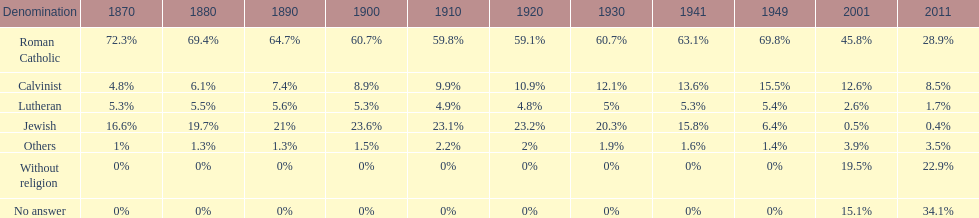Would you be able to parse every entry in this table? {'header': ['Denomination', '1870', '1880', '1890', '1900', '1910', '1920', '1930', '1941', '1949', '2001', '2011'], 'rows': [['Roman Catholic', '72.3%', '69.4%', '64.7%', '60.7%', '59.8%', '59.1%', '60.7%', '63.1%', '69.8%', '45.8%', '28.9%'], ['Calvinist', '4.8%', '6.1%', '7.4%', '8.9%', '9.9%', '10.9%', '12.1%', '13.6%', '15.5%', '12.6%', '8.5%'], ['Lutheran', '5.3%', '5.5%', '5.6%', '5.3%', '4.9%', '4.8%', '5%', '5.3%', '5.4%', '2.6%', '1.7%'], ['Jewish', '16.6%', '19.7%', '21%', '23.6%', '23.1%', '23.2%', '20.3%', '15.8%', '6.4%', '0.5%', '0.4%'], ['Others', '1%', '1.3%', '1.3%', '1.5%', '2.2%', '2%', '1.9%', '1.6%', '1.4%', '3.9%', '3.5%'], ['Without religion', '0%', '0%', '0%', '0%', '0%', '0%', '0%', '0%', '0%', '19.5%', '22.9%'], ['No answer', '0%', '0%', '0%', '0%', '0%', '0%', '0%', '0%', '0%', '15.1%', '34.1%']]} Between jewish and roman catholic, which religious community had a higher percentage in 1900? Roman Catholic. 